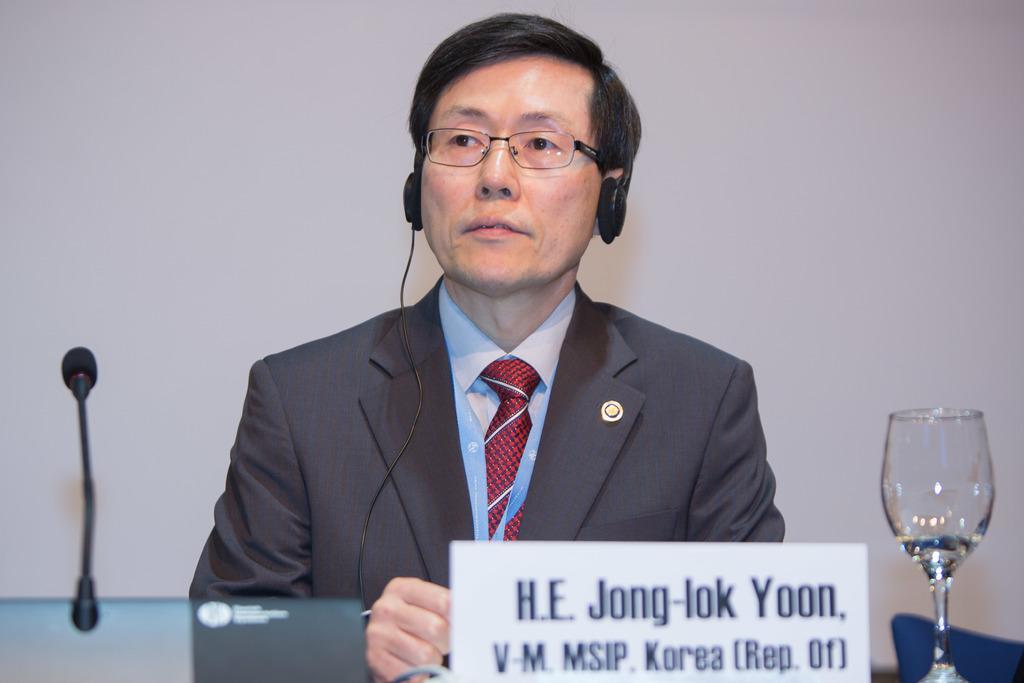How would you summarize this image in a sentence or two? In the foreground of the picture there are name plate, glass and mic. In the center of the picture there is a person wearing suit and headphones, behind him it is wall painted white, 